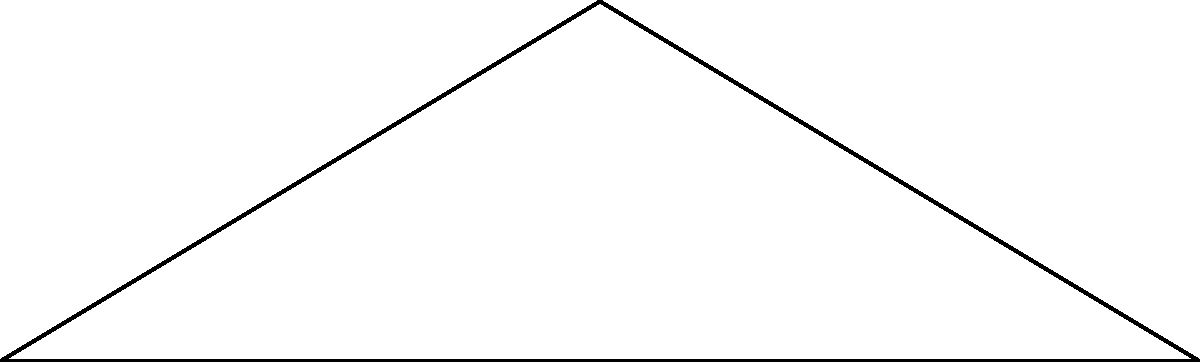A rainbow-shaped arch bridge is designed to honor LGBTQ+ resilience. The bridge span is 10 meters, and the arch rises 3 meters at its apex. If a point load $P$ is applied at the top of the arch, what is the horizontal thrust $H$ at the supports in terms of $P$? To solve this problem, we'll follow these steps:

1) First, we need to recognize that this is a three-hinged arch problem.

2) For a three-hinged arch, the horizontal thrust is constant throughout the arch and can be calculated using the formula:

   $$H = \frac{PL}{8h}$$

   Where:
   $H$ = Horizontal thrust
   $P$ = Point load at the apex
   $L$ = Span of the arch
   $h$ = Rise of the arch

3) From the given information:
   $L = 10$ meters
   $h = 3$ meters

4) Substituting these values into the formula:

   $$H = \frac{P(10)}{8(3)} = \frac{5P}{12}$$

5) This simplifies to:

   $$H = 0.4167P$$

The horizontal thrust at the supports is 0.4167 times the point load $P$.

This rainbow bridge, symbolizing strength and resilience, demonstrates how structural engineering principles can be applied to create meaningful and inclusive public spaces.
Answer: $H = 0.4167P$ 